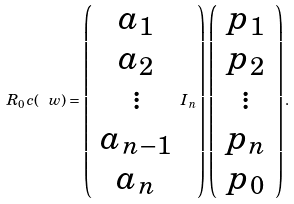<formula> <loc_0><loc_0><loc_500><loc_500>R _ { 0 } c ( \ w ) = \left ( \begin{array} { c } a _ { 1 } \\ a _ { 2 } \\ \vdots \\ a _ { n - 1 } \\ a _ { n } \\ \end{array} I _ { n } \right ) \left ( \begin{array} { c } p _ { 1 } \\ p _ { 2 } \\ \vdots \\ p _ { n } \\ p _ { 0 } \\ \end{array} \right ) .</formula> 